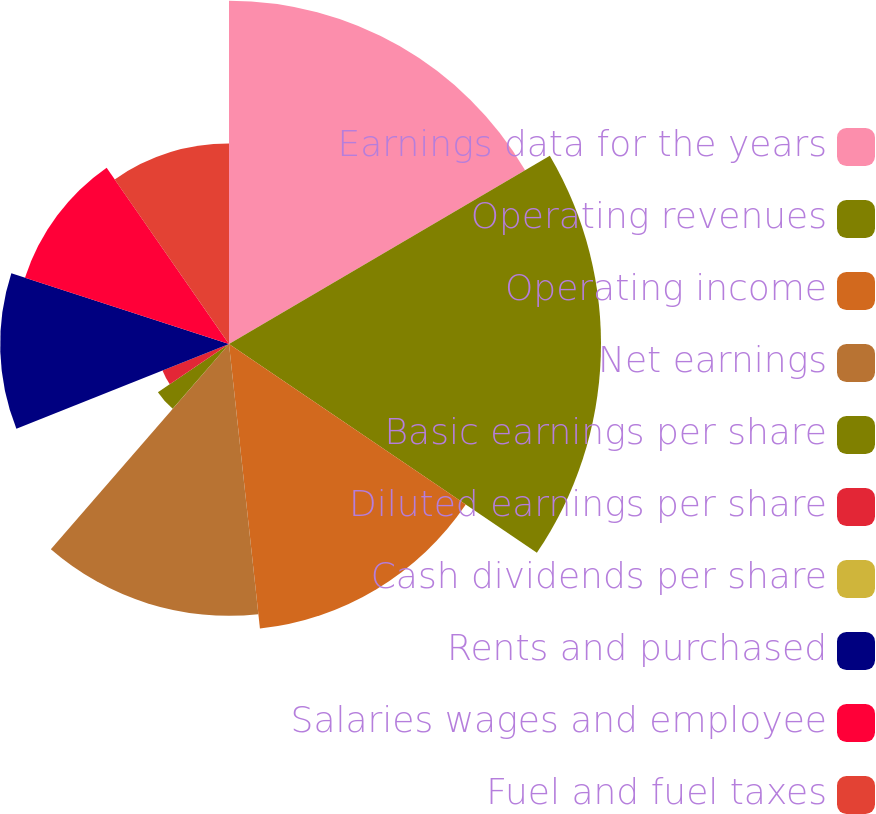Convert chart. <chart><loc_0><loc_0><loc_500><loc_500><pie_chart><fcel>Earnings data for the years<fcel>Operating revenues<fcel>Operating income<fcel>Net earnings<fcel>Basic earnings per share<fcel>Diluted earnings per share<fcel>Cash dividends per share<fcel>Rents and purchased<fcel>Salaries wages and employee<fcel>Fuel and fuel taxes<nl><fcel>16.55%<fcel>17.93%<fcel>13.79%<fcel>13.1%<fcel>4.14%<fcel>3.45%<fcel>0.0%<fcel>11.03%<fcel>10.34%<fcel>9.66%<nl></chart> 